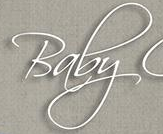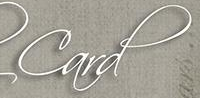What words can you see in these images in sequence, separated by a semicolon? Baby; Card 